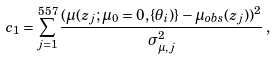<formula> <loc_0><loc_0><loc_500><loc_500>c _ { 1 } = \sum ^ { 5 5 7 } _ { j = 1 } \frac { ( \mu ( z _ { j } ; \mu _ { 0 } = 0 , \{ \theta _ { i } ) \} - \mu _ { o b s } ( z _ { j } ) ) ^ { 2 } } { \sigma ^ { 2 } _ { \mu , j } } \, ,</formula> 